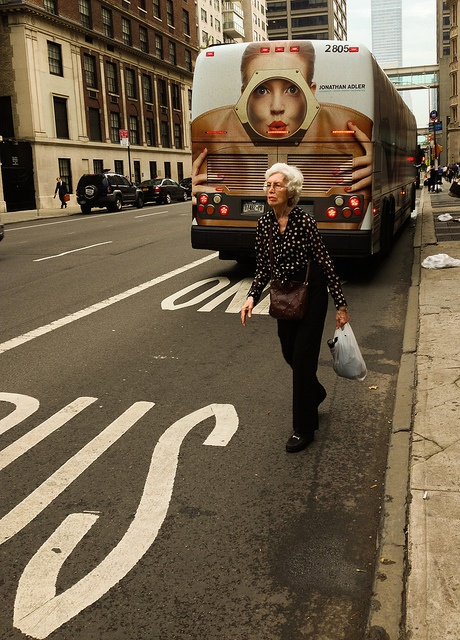Describe the objects in this image and their specific colors. I can see bus in darkgreen, black, maroon, and gray tones, people in darkgreen, black, maroon, and gray tones, car in darkgreen, black, gray, and maroon tones, handbag in darkgreen, black, maroon, and gray tones, and car in darkgreen, black, gray, and maroon tones in this image. 